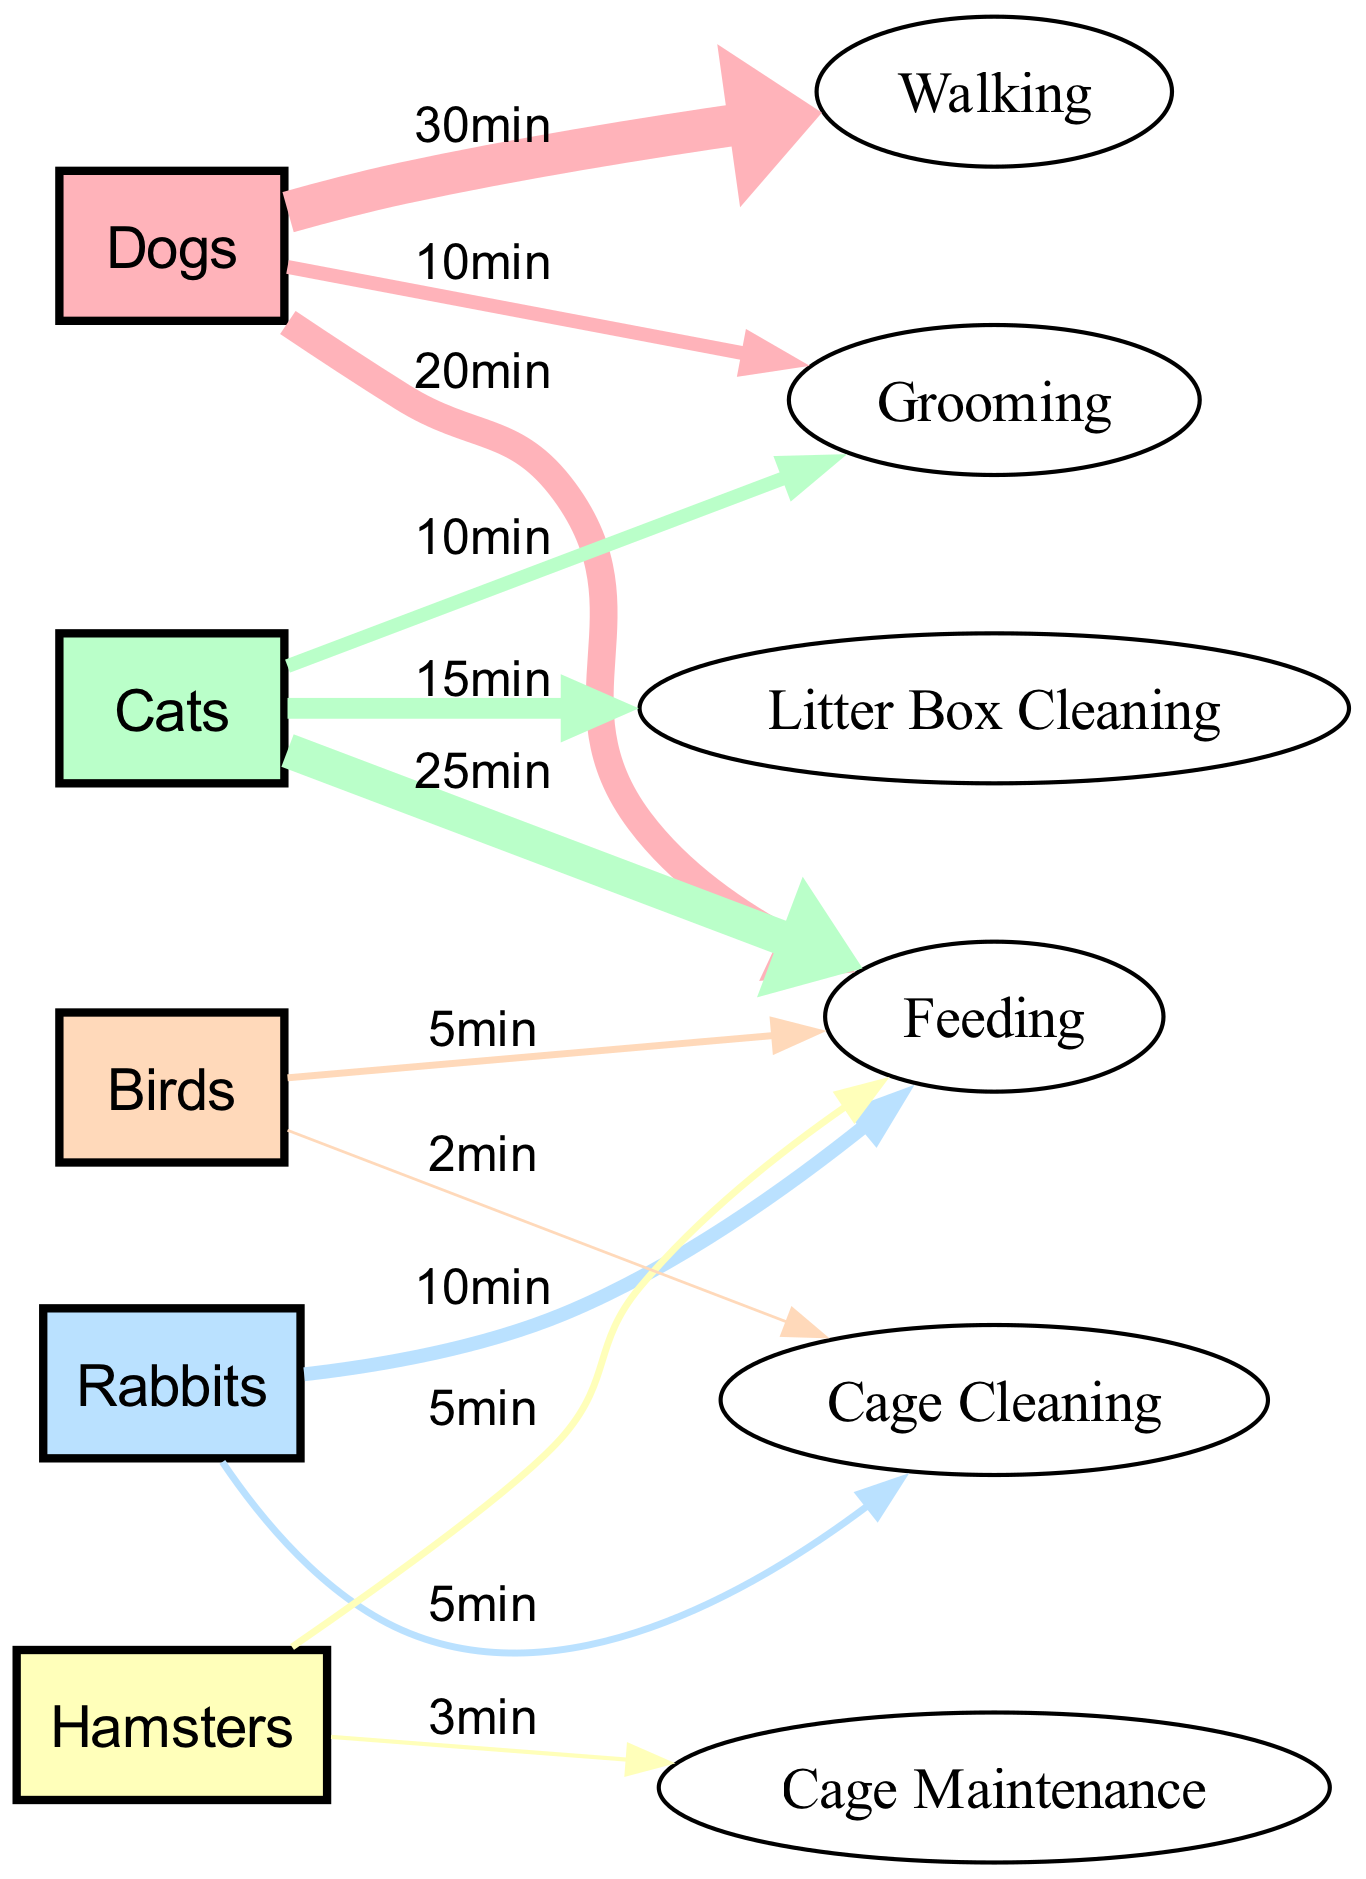What is the total time spent on caring for dogs? By examining the links connected to the "Dogs" node, we see that the times are 30 minutes for Walking, 20 minutes for Feeding, and 10 minutes for Grooming. Adding these values together: 30 + 20 + 10 = 60 minutes.
Answer: 60 minutes Which animal has the highest feeding time? The links show that the maximum feeding times are 20 minutes for Dogs, 25 minutes for Cats, 10 minutes for Rabbits, 5 minutes for Hamsters, and 5 minutes for Birds. The highest among these is 25 minutes for Cats.
Answer: Cats How many different pet types are represented in the diagram? The diagram includes nodes for Dogs, Cats, Rabbits, Hamsters, and Birds. Counting these gives us a total of 5 distinct types of pets.
Answer: 5 What is the total time spent on cage cleaning tasks? There are two nodes linked to "Cage Cleaning": 5 minutes from Rabbits and 2 minutes from Birds. Summing these gives us 5 + 2 = 7 minutes total.
Answer: 7 minutes What percentage of the total time spent on dogs is used for walking? The total time for dogs is 60 minutes and the walking time is 30 minutes. To find the percentage, we calculate (30/60) * 100 = 50%.
Answer: 50% Which pet requires the least amount of time for feeding? Looking at the feeding times: Dogs (20), Cats (25), Rabbits (10), Hamsters (5), and Birds (5). The minimum times for feeding are both 5 minutes for Hamsters and Birds.
Answer: Hamsters or Birds What is the total time spent on grooming for all pets? The grooming times listed are 10 minutes for Dogs, 10 minutes for Cats. Rabbits, Hamsters, and Birds have no grooming times recorded. Summing these gives us 10 + 10 = 20 minutes total.
Answer: 20 minutes What is the combined time spent on care tasks for small animals (Rabbits, Hamsters, and Birds)? For small animals, the care tasks include: Rabbits - 10 (Feeding) + 5 (Cage Cleaning) = 15 minutes, Hamsters - 5 (Feeding) + 3 (Cage Maintenance) = 8 minutes, Birds - 5 (Feeding) + 2 (Cage Cleaning) = 7 minutes. Adding these gives 15 + 8 + 7 = 30 minutes.
Answer: 30 minutes What is the relationship between feeding time and grooming for Cats? The link shows that Cats have 25 minutes for Feeding and 10 minutes for Grooming, indicating that grooming takes up less time compared to feeding.
Answer: Less time 